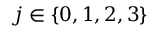Convert formula to latex. <formula><loc_0><loc_0><loc_500><loc_500>j \in \{ 0 , 1 , 2 , 3 \}</formula> 